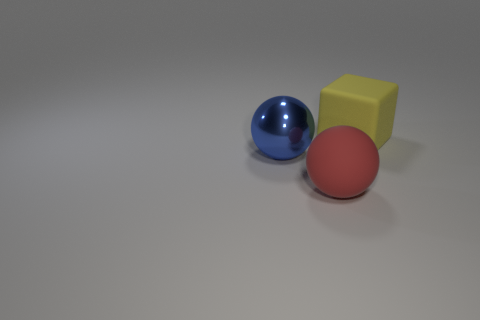Are there any other things that are made of the same material as the big blue object?
Provide a short and direct response. No. There is a large ball that is behind the rubber thing left of the thing that is behind the blue shiny object; what is its color?
Offer a terse response. Blue. Do the yellow rubber thing and the metallic sphere have the same size?
Keep it short and to the point. Yes. Is there any other thing that is the same shape as the blue object?
Your answer should be compact. Yes. How many objects are either things behind the big red sphere or large red matte spheres?
Keep it short and to the point. 3. Is the red object the same shape as the yellow matte thing?
Offer a very short reply. No. How many other things are the same size as the shiny object?
Your answer should be compact. 2. The big metal thing has what color?
Your response must be concise. Blue. What number of large objects are either gray rubber spheres or things?
Your answer should be very brief. 3. There is a object behind the shiny sphere; is its size the same as the rubber object that is in front of the large metallic object?
Keep it short and to the point. Yes. 